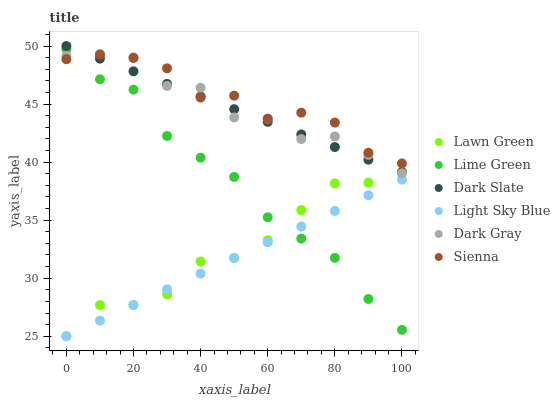Does Light Sky Blue have the minimum area under the curve?
Answer yes or no. Yes. Does Sienna have the maximum area under the curve?
Answer yes or no. Yes. Does Dark Slate have the minimum area under the curve?
Answer yes or no. No. Does Dark Slate have the maximum area under the curve?
Answer yes or no. No. Is Dark Slate the smoothest?
Answer yes or no. Yes. Is Dark Gray the roughest?
Answer yes or no. Yes. Is Dark Gray the smoothest?
Answer yes or no. No. Is Dark Slate the roughest?
Answer yes or no. No. Does Lawn Green have the lowest value?
Answer yes or no. Yes. Does Dark Slate have the lowest value?
Answer yes or no. No. Does Dark Slate have the highest value?
Answer yes or no. Yes. Does Dark Gray have the highest value?
Answer yes or no. No. Is Lime Green less than Dark Slate?
Answer yes or no. Yes. Is Dark Slate greater than Light Sky Blue?
Answer yes or no. Yes. Does Sienna intersect Lime Green?
Answer yes or no. Yes. Is Sienna less than Lime Green?
Answer yes or no. No. Is Sienna greater than Lime Green?
Answer yes or no. No. Does Lime Green intersect Dark Slate?
Answer yes or no. No. 